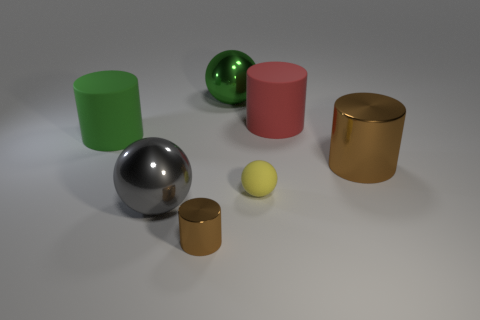There is a sphere behind the big green cylinder; what is its size?
Provide a short and direct response. Large. There is a shiny cylinder that is in front of the yellow matte ball; does it have the same color as the large shiny cylinder?
Your answer should be compact. Yes. What is the shape of the tiny object that is behind the metallic sphere to the left of the small brown metallic cylinder?
Provide a short and direct response. Sphere. Are there any other things that are the same shape as the small brown thing?
Provide a short and direct response. Yes. What is the color of the other big matte thing that is the same shape as the large red matte thing?
Keep it short and to the point. Green. There is a tiny cylinder; is it the same color as the metallic sphere that is in front of the big brown thing?
Provide a short and direct response. No. There is a object that is both behind the large brown thing and on the left side of the large green metallic sphere; what shape is it?
Ensure brevity in your answer.  Cylinder. Are there fewer big green shiny spheres than small cyan shiny blocks?
Offer a very short reply. No. Are any matte things visible?
Your response must be concise. Yes. How many other objects are the same size as the yellow object?
Your answer should be compact. 1. 